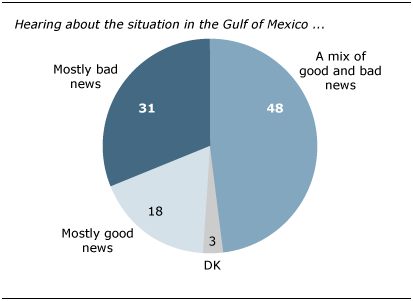Mention a couple of crucial points in this snapshot. There is a significant difference between mostly bad news and a mix of good and bad news. Mostly Bad news shows have a limited value of 31. 